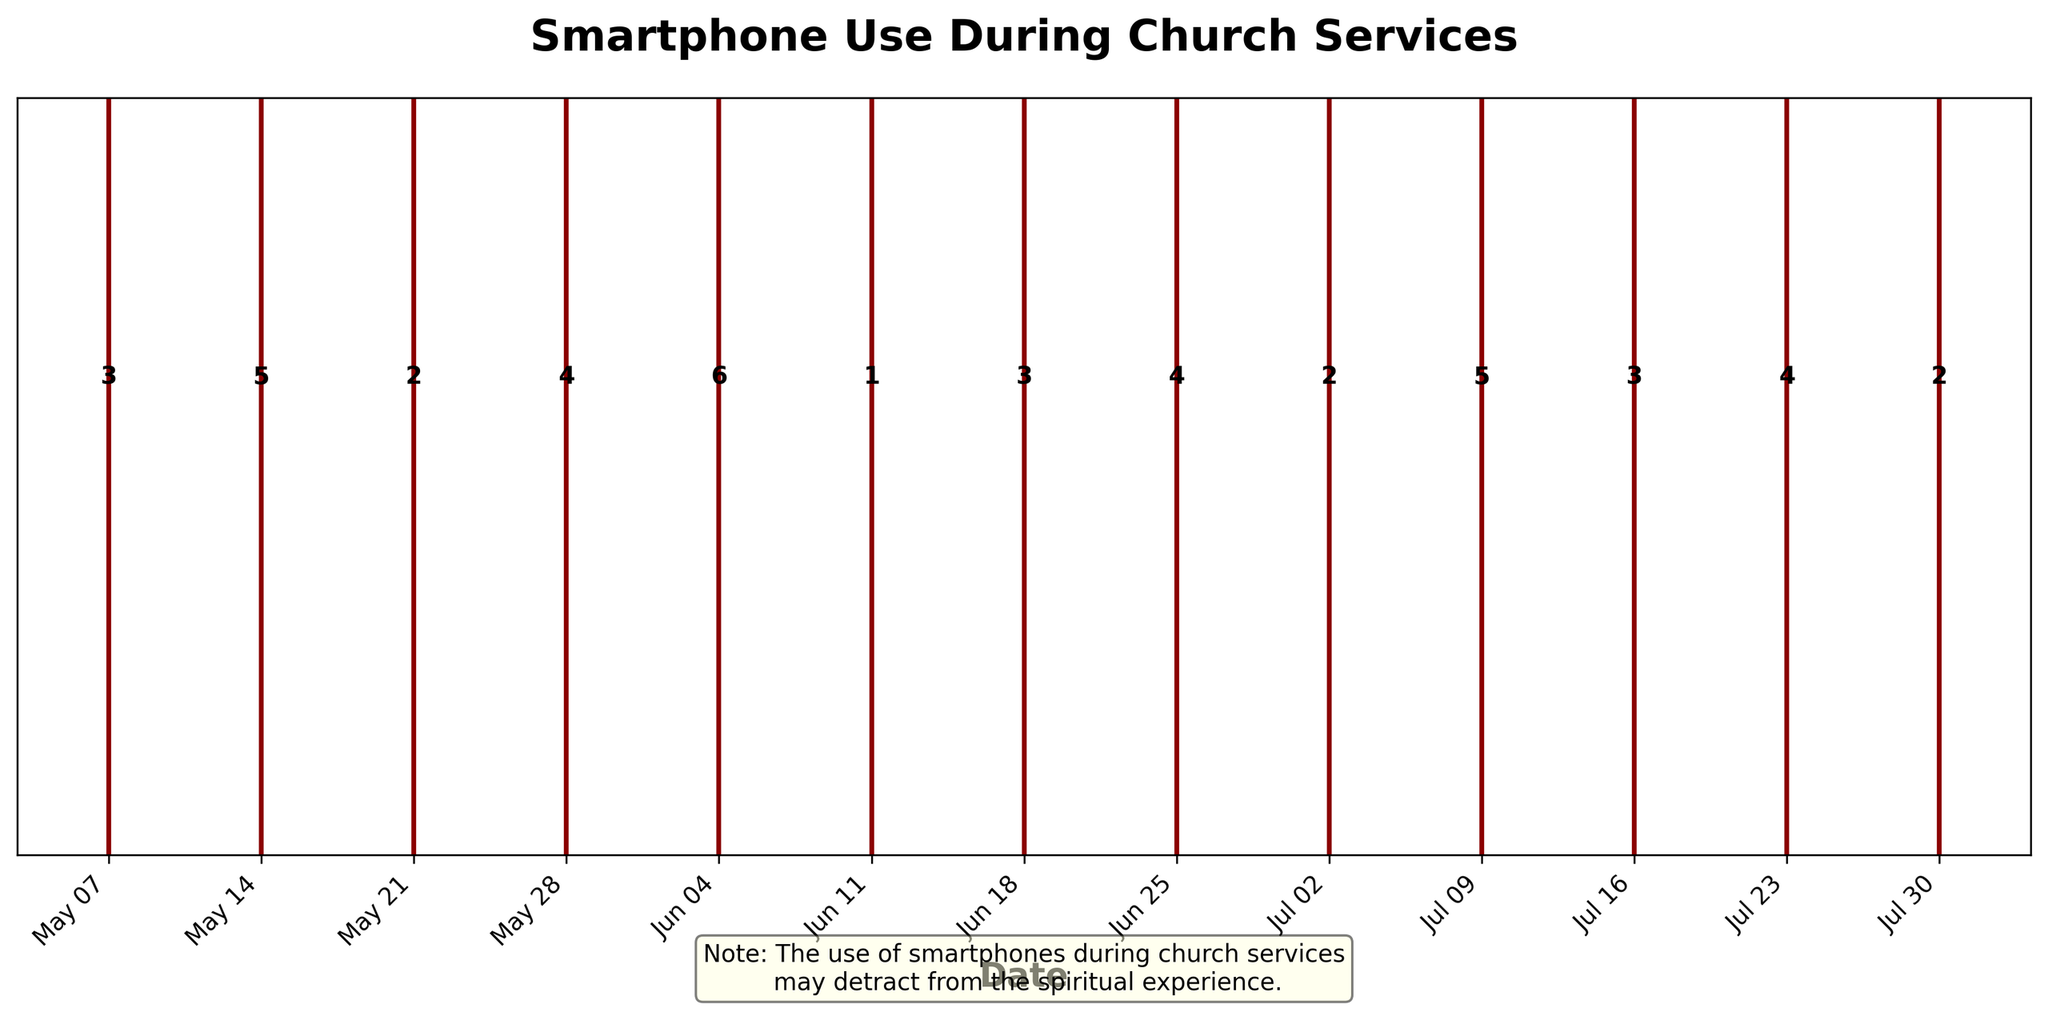What is the title of the figure? The title of the figure can be found at the top of the plot.
Answer: Smartphone Use During Church Services What are the dates with the highest occurrence of smartphone use? The dates with the highest occurrences are those with the largest numbers annotated above the event lines.
Answer: 2023-06-04 and 2023-07-09 How many data points were recorded in June? Look at the annotations and event lines above the dates within June (2023-06-04, 2023-06-11, 2023-06-18, 2023-06-25).
Answer: 4 What is the average occurrence of smartphone use over May? Sum the occurrences in May (3 + 5 + 2 + 4) and divide by the number of Sundays in May (4). Average = (3 + 5 + 2 + 4) / 4 = 3.5
Answer: 3.5 On which date was smartphone use the lowest? Identify the date with the smallest number annotated above the event lines.
Answer: 2023-06-11 What is the trend of smartphone use from June to July? Compare the occurrences in June (6, 1, 3, 4) to those in July (2, 5, 3, 4, 2).
Answer: Decreasing Which month had the most occurrences of smartphone use overall? Sum up the occurrences month by month: May (3 + 5 + 2 + 4), June (6 + 1 + 3 + 4), July (2 + 5 + 3 + 4 + 2). May = 14, June = 14, July = 16.
Answer: July Is there a noticeable pattern in smartphone use at church services over the months shown? Analyze the occurrence numbers and see if there's an up or down trend, or any cyclic pattern month-wise.
Answer: No clear pattern How does smartphone use on 2023-06-04 compare to 2023-06-11? Look at the occurrences on these dates: 2023-06-04 (6), 2023-06-11 (1). Compare their annotation values.
Answer: 2023-06-04 is higher What does the cautionary note at the bottom of the plot indicate about smartphone use during church services? Read the warning text provided at the bottom of the plot.
Answer: It may detract from the spiritual experience 